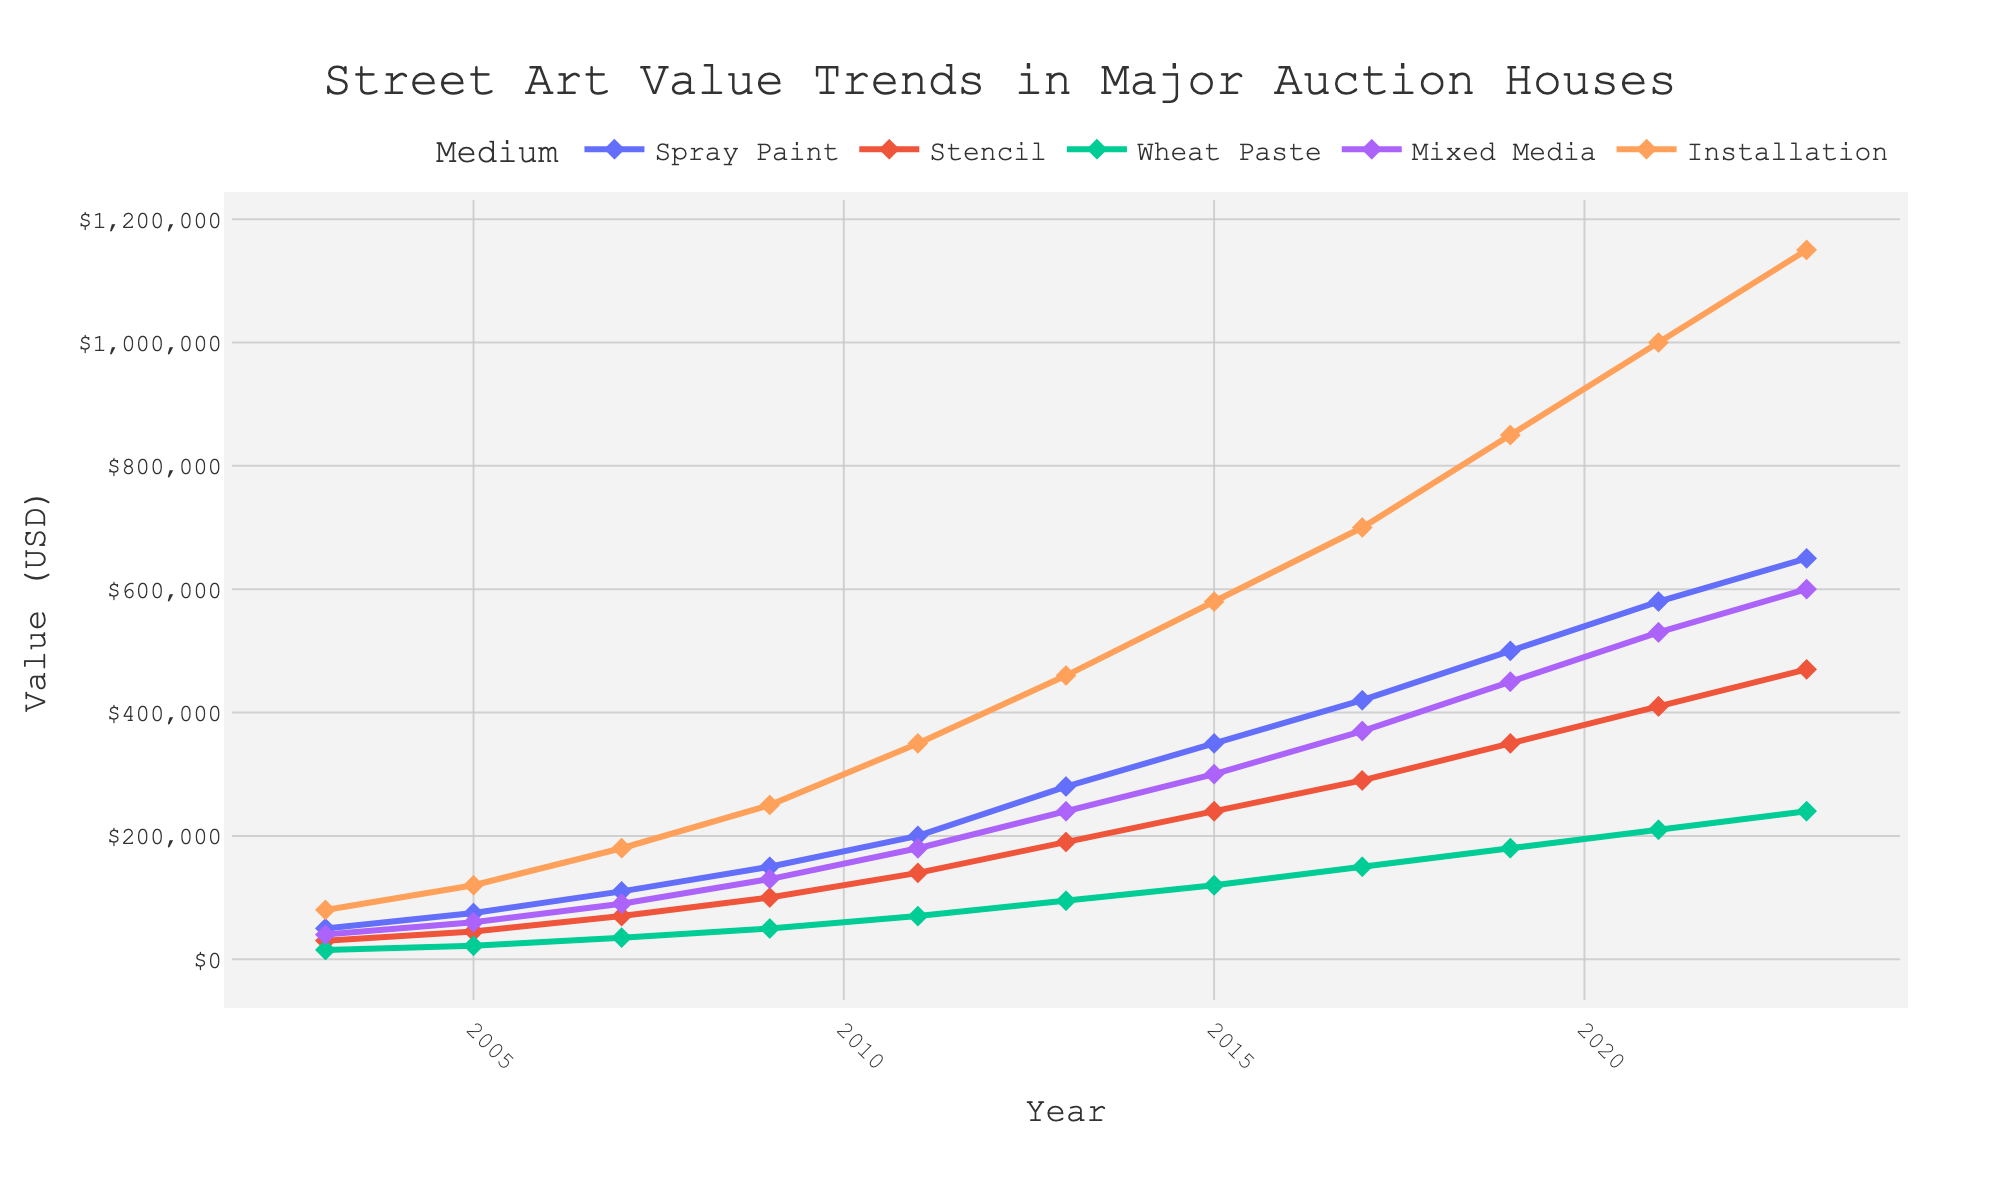What's the trend in the value of Spray Paint over the 20 years? Look at the Spray Paint line, which starts at $50,000 in 2003 and steadily rises to $650,000 in 2023.
Answer: Steady increase Which medium saw the highest increase in value from 2003 to 2023? Compare the difference in value for each medium from 2003 to 2023. Installation increased from $80,000 to $1,150,000, which is the highest increase among all the mediums.
Answer: Installation How does the value of Stencil in 2023 compare to Mixed Media in 2011? In 2023, Stencil has a value of $470,000. Mixed Media in 2011 is valued at $180,000. Thus, $470,000 is more than $180,000.
Answer: Stencil is higher Which year did Spray Paint surpass the $200,000 mark? Check the values for Spray Paint and identify the first year it exceeds $200,000, which happens in 2011 with a value of $200,000.
Answer: 2011 Which medium had the smallest increase in value from 2003 to 2023? Calculate the difference for each medium. Wheat Paste increases from $15,000 in 2003 to $240,000 in 2023, which is the smallest increase.
Answer: Wheat Paste What is the difference in value between Spray Paint and Installation in 2023? Subtract the value of Spray Paint in 2023 ($650,000) from the value of Installation in 2023 ($1,150,000). The difference is $1,150,000 - $650,000 = $500,000.
Answer: $500,000 How does the rate of increase in value of Mixed Media from 2015 to 2019 compare to Stencil in the same period? Mixed Media increases from $300,000 in 2015 to $450,000 in 2019, an increase of $150,000. Stencil increases from $240,000 to $350,000, an increase of $110,000. Therefore, Mixed Media’s rate of increase is greater.
Answer: Mixed Media increased more 